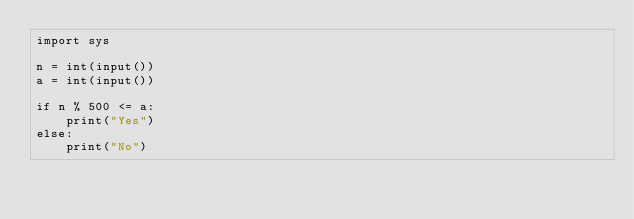<code> <loc_0><loc_0><loc_500><loc_500><_Python_>import sys

n = int(input())
a = int(input())

if n % 500 <= a:
    print("Yes")
else:
    print("No")</code> 